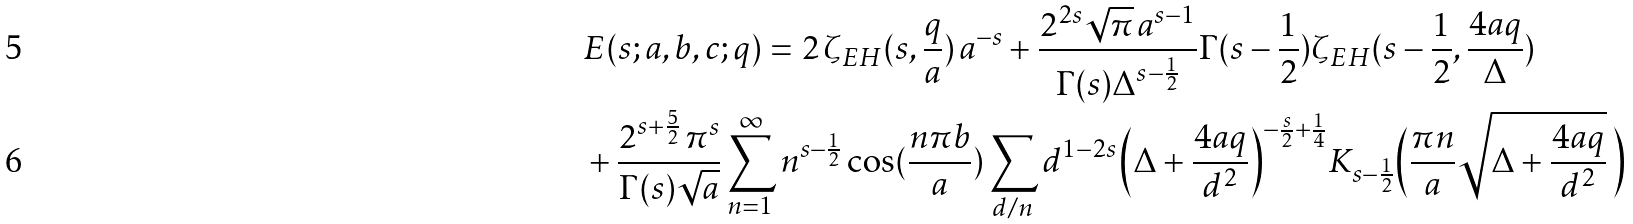<formula> <loc_0><loc_0><loc_500><loc_500>& E ( s ; a , b , c ; q ) = 2 { \, } \zeta _ { E H } ( s , \frac { q } { a } ) { \, } a ^ { - s } + \frac { 2 ^ { 2 s } \sqrt { \pi } { \, } a ^ { s - 1 } } { \Gamma ( s ) \Delta ^ { s - \frac { 1 } { 2 } } } \Gamma ( s - \frac { 1 } { 2 } ) \zeta _ { E H } ( s - \frac { 1 } { 2 } , \frac { 4 a q } { \Delta } ) \\ & + \frac { 2 ^ { s + \frac { 5 } { 2 } } { \, } \pi ^ { s } } { \Gamma ( s ) \sqrt { a } } \sum _ { n = 1 } ^ { \infty } n ^ { s - \frac { 1 } { 2 } } \cos ( \frac { n \pi b } { a } ) \sum _ { d / n } d ^ { 1 - 2 s } \Big { ( } \Delta + \frac { 4 a q } { d ^ { 2 } } \Big { ) } ^ { - \frac { s } { 2 } + \frac { 1 } { 4 } } K _ { s - \frac { 1 } { 2 } } \Big { ( } \frac { \pi n } { a } \sqrt { \Delta + \frac { 4 a q } { d ^ { 2 } } } { \, } \Big { ) }</formula> 